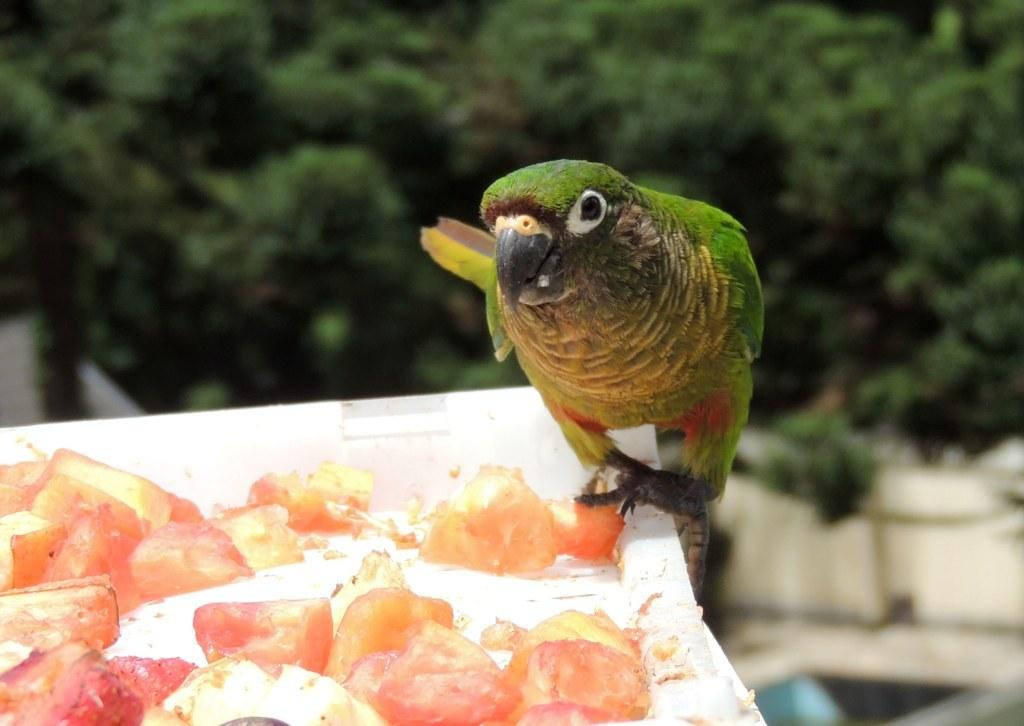What type of animal can be seen in the image? There is a bird in the image. What is on the white surface in the image? There are food items on a white surface in the image. What can be seen in the background of the image? There is a group of trees in the background of the image. How would you describe the background of the image? The background of the image is blurred. What type of brass instrument is being played by the bird in the image? There is no brass instrument present in the image, and the bird is not playing any instrument. 